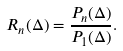<formula> <loc_0><loc_0><loc_500><loc_500>R _ { n } ( \Delta ) = \frac { P _ { n } ( \Delta ) } { P _ { 1 } ( \Delta ) } .</formula> 